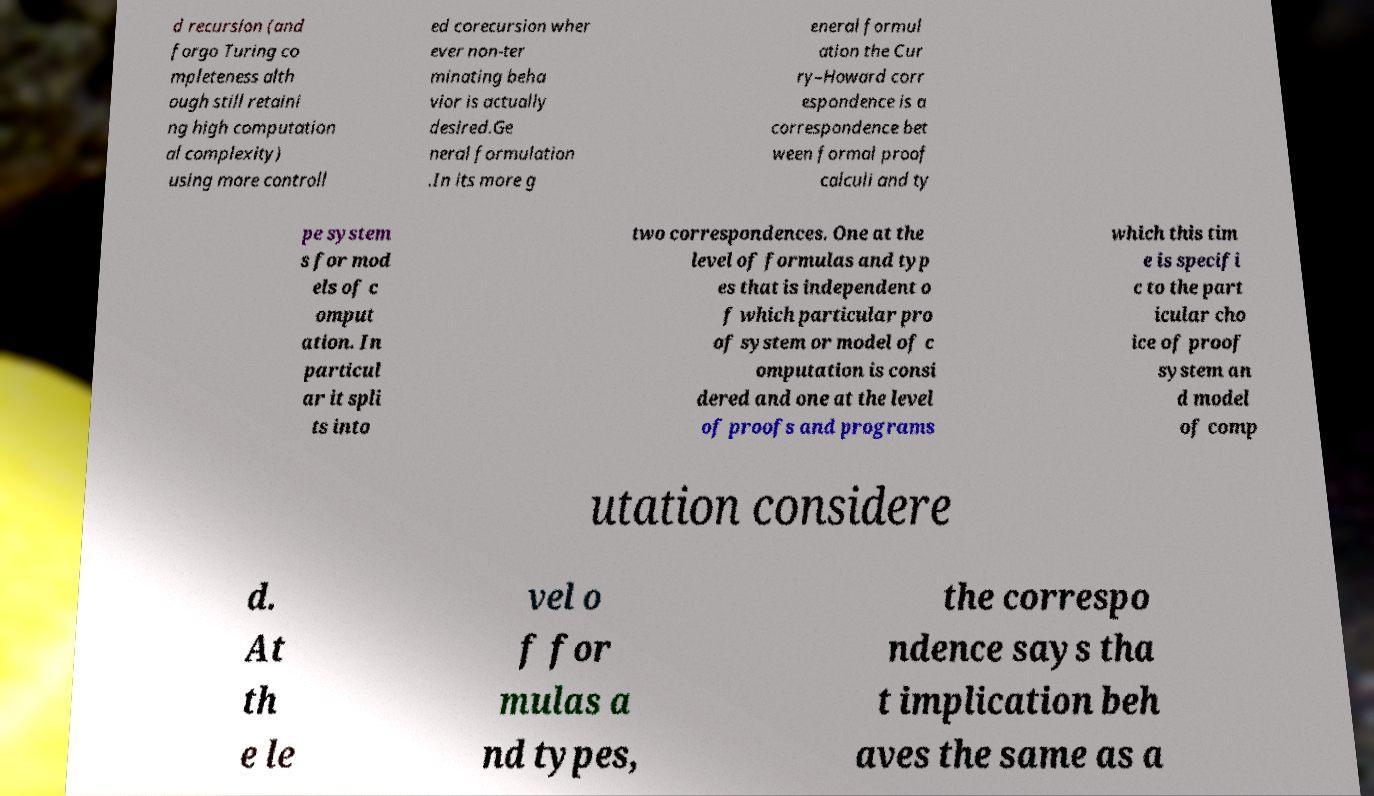Please identify and transcribe the text found in this image. d recursion (and forgo Turing co mpleteness alth ough still retaini ng high computation al complexity) using more controll ed corecursion wher ever non-ter minating beha vior is actually desired.Ge neral formulation .In its more g eneral formul ation the Cur ry–Howard corr espondence is a correspondence bet ween formal proof calculi and ty pe system s for mod els of c omput ation. In particul ar it spli ts into two correspondences. One at the level of formulas and typ es that is independent o f which particular pro of system or model of c omputation is consi dered and one at the level of proofs and programs which this tim e is specifi c to the part icular cho ice of proof system an d model of comp utation considere d. At th e le vel o f for mulas a nd types, the correspo ndence says tha t implication beh aves the same as a 